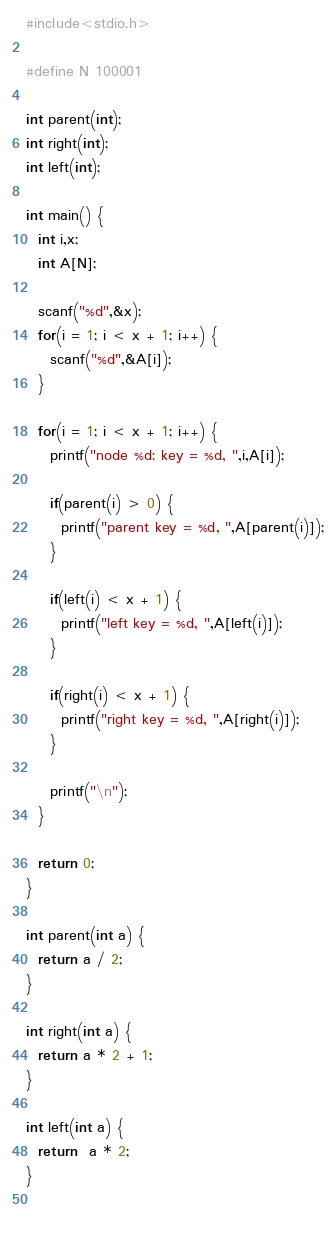<code> <loc_0><loc_0><loc_500><loc_500><_C_>#include<stdio.h>

#define N 100001

int parent(int);
int right(int);
int left(int);

int main() {
  int i,x;
  int A[N];

  scanf("%d",&x);
  for(i = 1; i < x + 1; i++) {
    scanf("%d",&A[i]);
  }

  for(i = 1; i < x + 1; i++) {
    printf("node %d: key = %d, ",i,A[i]);

    if(parent(i) > 0) {
      printf("parent key = %d, ",A[parent(i)]);
    }

    if(left(i) < x + 1) {
      printf("left key = %d, ",A[left(i)]);
    }

    if(right(i) < x + 1) {
      printf("right key = %d, ",A[right(i)]);
    }

    printf("\n");
  }

  return 0;
}

int parent(int a) {
  return a / 2;
}

int right(int a) {
  return a * 2 + 1;
}

int left(int a) {
  return  a * 2;
}

    

</code> 